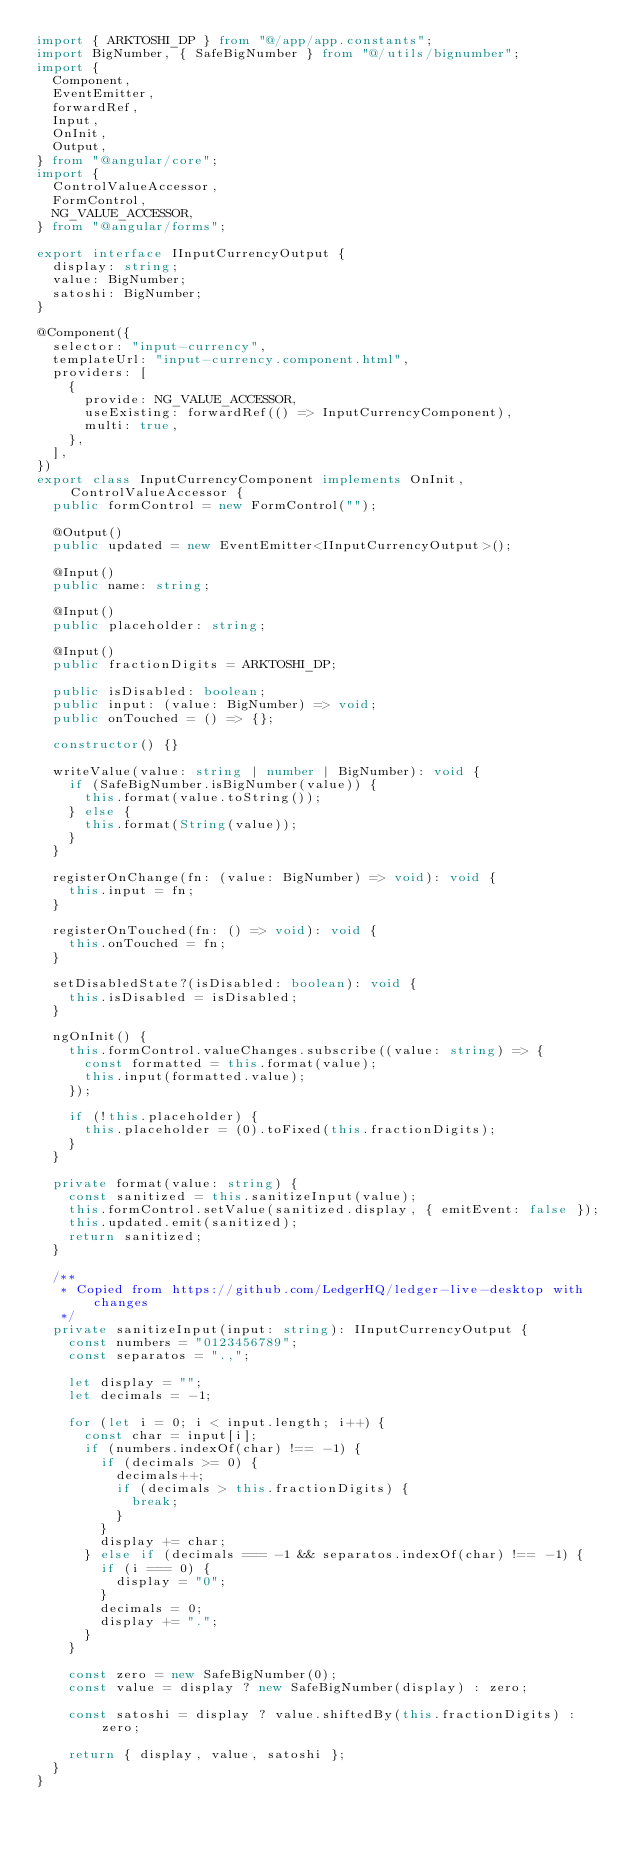<code> <loc_0><loc_0><loc_500><loc_500><_TypeScript_>import { ARKTOSHI_DP } from "@/app/app.constants";
import BigNumber, { SafeBigNumber } from "@/utils/bignumber";
import {
	Component,
	EventEmitter,
	forwardRef,
	Input,
	OnInit,
	Output,
} from "@angular/core";
import {
	ControlValueAccessor,
	FormControl,
	NG_VALUE_ACCESSOR,
} from "@angular/forms";

export interface IInputCurrencyOutput {
	display: string;
	value: BigNumber;
	satoshi: BigNumber;
}

@Component({
	selector: "input-currency",
	templateUrl: "input-currency.component.html",
	providers: [
		{
			provide: NG_VALUE_ACCESSOR,
			useExisting: forwardRef(() => InputCurrencyComponent),
			multi: true,
		},
	],
})
export class InputCurrencyComponent implements OnInit, ControlValueAccessor {
	public formControl = new FormControl("");

	@Output()
	public updated = new EventEmitter<IInputCurrencyOutput>();

	@Input()
	public name: string;

	@Input()
	public placeholder: string;

	@Input()
	public fractionDigits = ARKTOSHI_DP;

	public isDisabled: boolean;
	public input: (value: BigNumber) => void;
	public onTouched = () => {};

	constructor() {}

	writeValue(value: string | number | BigNumber): void {
		if (SafeBigNumber.isBigNumber(value)) {
			this.format(value.toString());
		} else {
			this.format(String(value));
		}
	}

	registerOnChange(fn: (value: BigNumber) => void): void {
		this.input = fn;
	}

	registerOnTouched(fn: () => void): void {
		this.onTouched = fn;
	}

	setDisabledState?(isDisabled: boolean): void {
		this.isDisabled = isDisabled;
	}

	ngOnInit() {
		this.formControl.valueChanges.subscribe((value: string) => {
			const formatted = this.format(value);
			this.input(formatted.value);
		});

		if (!this.placeholder) {
			this.placeholder = (0).toFixed(this.fractionDigits);
		}
	}

	private format(value: string) {
		const sanitized = this.sanitizeInput(value);
		this.formControl.setValue(sanitized.display, { emitEvent: false });
		this.updated.emit(sanitized);
		return sanitized;
	}

	/**
	 * Copied from https://github.com/LedgerHQ/ledger-live-desktop with changes
	 */
	private sanitizeInput(input: string): IInputCurrencyOutput {
		const numbers = "0123456789";
		const separatos = ".,";

		let display = "";
		let decimals = -1;

		for (let i = 0; i < input.length; i++) {
			const char = input[i];
			if (numbers.indexOf(char) !== -1) {
				if (decimals >= 0) {
					decimals++;
					if (decimals > this.fractionDigits) {
						break;
					}
				}
				display += char;
			} else if (decimals === -1 && separatos.indexOf(char) !== -1) {
				if (i === 0) {
					display = "0";
				}
				decimals = 0;
				display += ".";
			}
		}

		const zero = new SafeBigNumber(0);
		const value = display ? new SafeBigNumber(display) : zero;

		const satoshi = display ? value.shiftedBy(this.fractionDigits) : zero;

		return { display, value, satoshi };
	}
}
</code> 